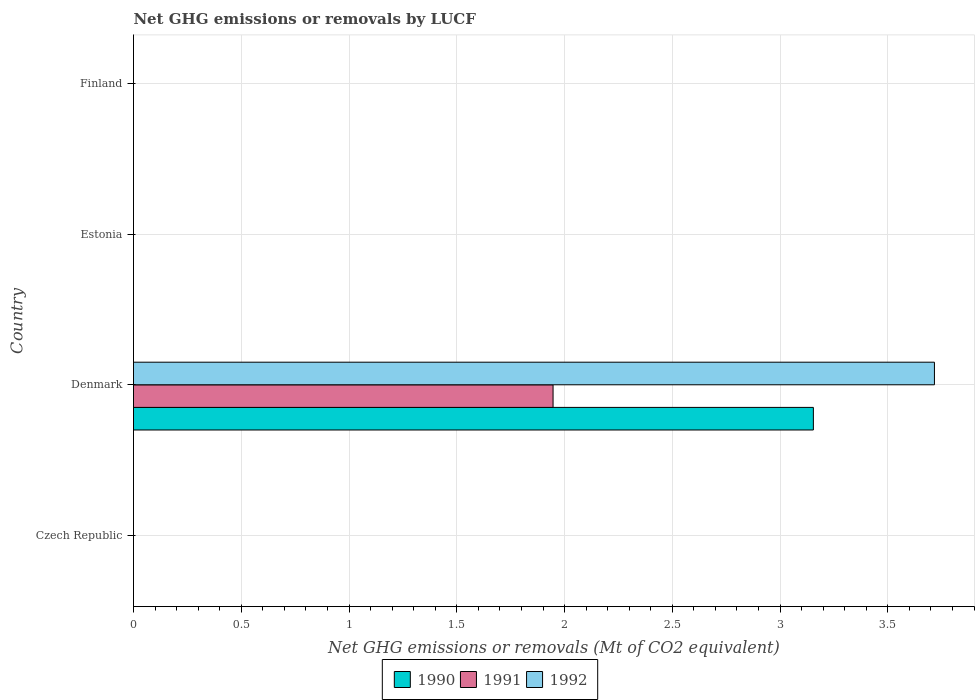Are the number of bars on each tick of the Y-axis equal?
Provide a succinct answer. No. What is the label of the 4th group of bars from the top?
Your answer should be very brief. Czech Republic. In how many cases, is the number of bars for a given country not equal to the number of legend labels?
Ensure brevity in your answer.  3. What is the net GHG emissions or removals by LUCF in 1991 in Estonia?
Provide a succinct answer. 0. Across all countries, what is the maximum net GHG emissions or removals by LUCF in 1992?
Your answer should be compact. 3.72. Across all countries, what is the minimum net GHG emissions or removals by LUCF in 1992?
Give a very brief answer. 0. What is the total net GHG emissions or removals by LUCF in 1990 in the graph?
Give a very brief answer. 3.15. What is the difference between the net GHG emissions or removals by LUCF in 1991 in Denmark and the net GHG emissions or removals by LUCF in 1992 in Czech Republic?
Offer a terse response. 1.95. What is the average net GHG emissions or removals by LUCF in 1990 per country?
Give a very brief answer. 0.79. What is the difference between the net GHG emissions or removals by LUCF in 1991 and net GHG emissions or removals by LUCF in 1990 in Denmark?
Offer a terse response. -1.21. In how many countries, is the net GHG emissions or removals by LUCF in 1990 greater than 2.9 Mt?
Give a very brief answer. 1. What is the difference between the highest and the lowest net GHG emissions or removals by LUCF in 1992?
Provide a succinct answer. 3.72. Are all the bars in the graph horizontal?
Your answer should be compact. Yes. What is the difference between two consecutive major ticks on the X-axis?
Your answer should be very brief. 0.5. Are the values on the major ticks of X-axis written in scientific E-notation?
Your answer should be very brief. No. How are the legend labels stacked?
Ensure brevity in your answer.  Horizontal. What is the title of the graph?
Keep it short and to the point. Net GHG emissions or removals by LUCF. What is the label or title of the X-axis?
Offer a very short reply. Net GHG emissions or removals (Mt of CO2 equivalent). What is the label or title of the Y-axis?
Keep it short and to the point. Country. What is the Net GHG emissions or removals (Mt of CO2 equivalent) in 1990 in Czech Republic?
Your answer should be compact. 0. What is the Net GHG emissions or removals (Mt of CO2 equivalent) of 1991 in Czech Republic?
Your response must be concise. 0. What is the Net GHG emissions or removals (Mt of CO2 equivalent) in 1990 in Denmark?
Provide a succinct answer. 3.15. What is the Net GHG emissions or removals (Mt of CO2 equivalent) in 1991 in Denmark?
Give a very brief answer. 1.95. What is the Net GHG emissions or removals (Mt of CO2 equivalent) in 1992 in Denmark?
Your answer should be very brief. 3.72. What is the Net GHG emissions or removals (Mt of CO2 equivalent) in 1991 in Finland?
Ensure brevity in your answer.  0. What is the Net GHG emissions or removals (Mt of CO2 equivalent) in 1992 in Finland?
Give a very brief answer. 0. Across all countries, what is the maximum Net GHG emissions or removals (Mt of CO2 equivalent) of 1990?
Keep it short and to the point. 3.15. Across all countries, what is the maximum Net GHG emissions or removals (Mt of CO2 equivalent) of 1991?
Your answer should be very brief. 1.95. Across all countries, what is the maximum Net GHG emissions or removals (Mt of CO2 equivalent) of 1992?
Provide a succinct answer. 3.72. Across all countries, what is the minimum Net GHG emissions or removals (Mt of CO2 equivalent) in 1990?
Your response must be concise. 0. What is the total Net GHG emissions or removals (Mt of CO2 equivalent) in 1990 in the graph?
Ensure brevity in your answer.  3.15. What is the total Net GHG emissions or removals (Mt of CO2 equivalent) of 1991 in the graph?
Your response must be concise. 1.95. What is the total Net GHG emissions or removals (Mt of CO2 equivalent) of 1992 in the graph?
Keep it short and to the point. 3.72. What is the average Net GHG emissions or removals (Mt of CO2 equivalent) in 1990 per country?
Give a very brief answer. 0.79. What is the average Net GHG emissions or removals (Mt of CO2 equivalent) in 1991 per country?
Provide a succinct answer. 0.49. What is the average Net GHG emissions or removals (Mt of CO2 equivalent) in 1992 per country?
Your answer should be very brief. 0.93. What is the difference between the Net GHG emissions or removals (Mt of CO2 equivalent) in 1990 and Net GHG emissions or removals (Mt of CO2 equivalent) in 1991 in Denmark?
Provide a short and direct response. 1.21. What is the difference between the Net GHG emissions or removals (Mt of CO2 equivalent) of 1990 and Net GHG emissions or removals (Mt of CO2 equivalent) of 1992 in Denmark?
Your response must be concise. -0.56. What is the difference between the Net GHG emissions or removals (Mt of CO2 equivalent) of 1991 and Net GHG emissions or removals (Mt of CO2 equivalent) of 1992 in Denmark?
Your response must be concise. -1.77. What is the difference between the highest and the lowest Net GHG emissions or removals (Mt of CO2 equivalent) in 1990?
Provide a short and direct response. 3.15. What is the difference between the highest and the lowest Net GHG emissions or removals (Mt of CO2 equivalent) in 1991?
Your answer should be very brief. 1.95. What is the difference between the highest and the lowest Net GHG emissions or removals (Mt of CO2 equivalent) in 1992?
Your answer should be compact. 3.72. 